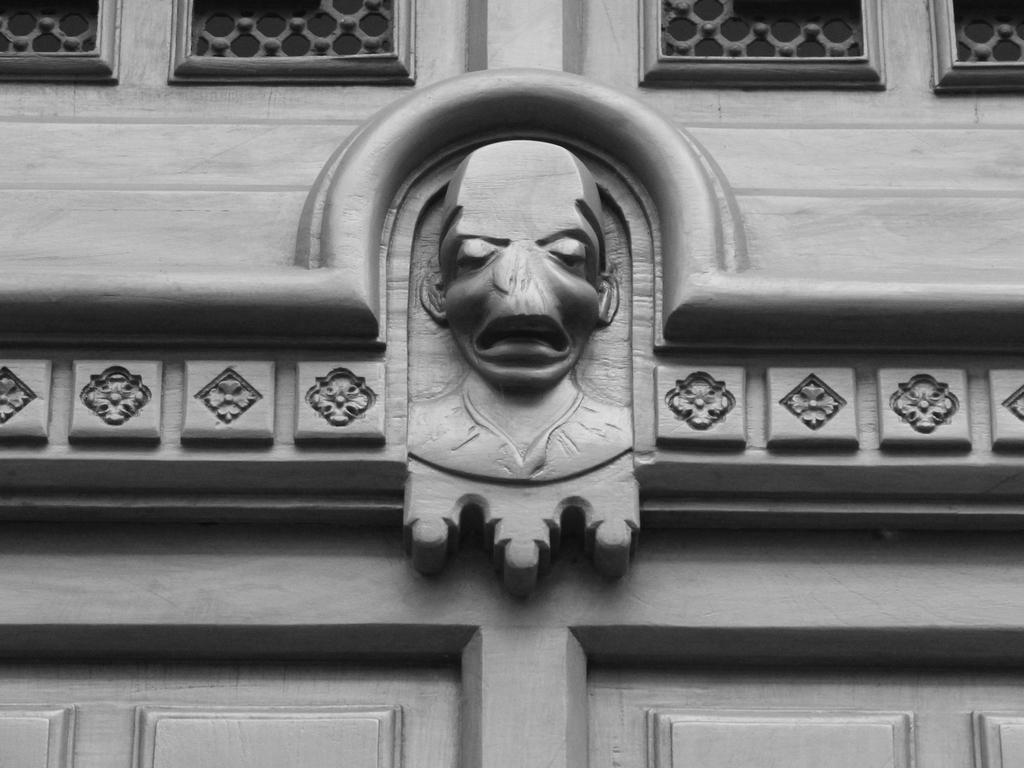What is the main subject of the image? There is a sculpture in the image. Where is the sculpture located? The sculpture is on a building. How is the sculpture positioned in the image? The sculpture is in the center of the image. What type of cork can be seen in the image? There is no cork present in the image. How many planes are flying in the image? There is no mention of planes in the image; it features a sculpture on a building. 